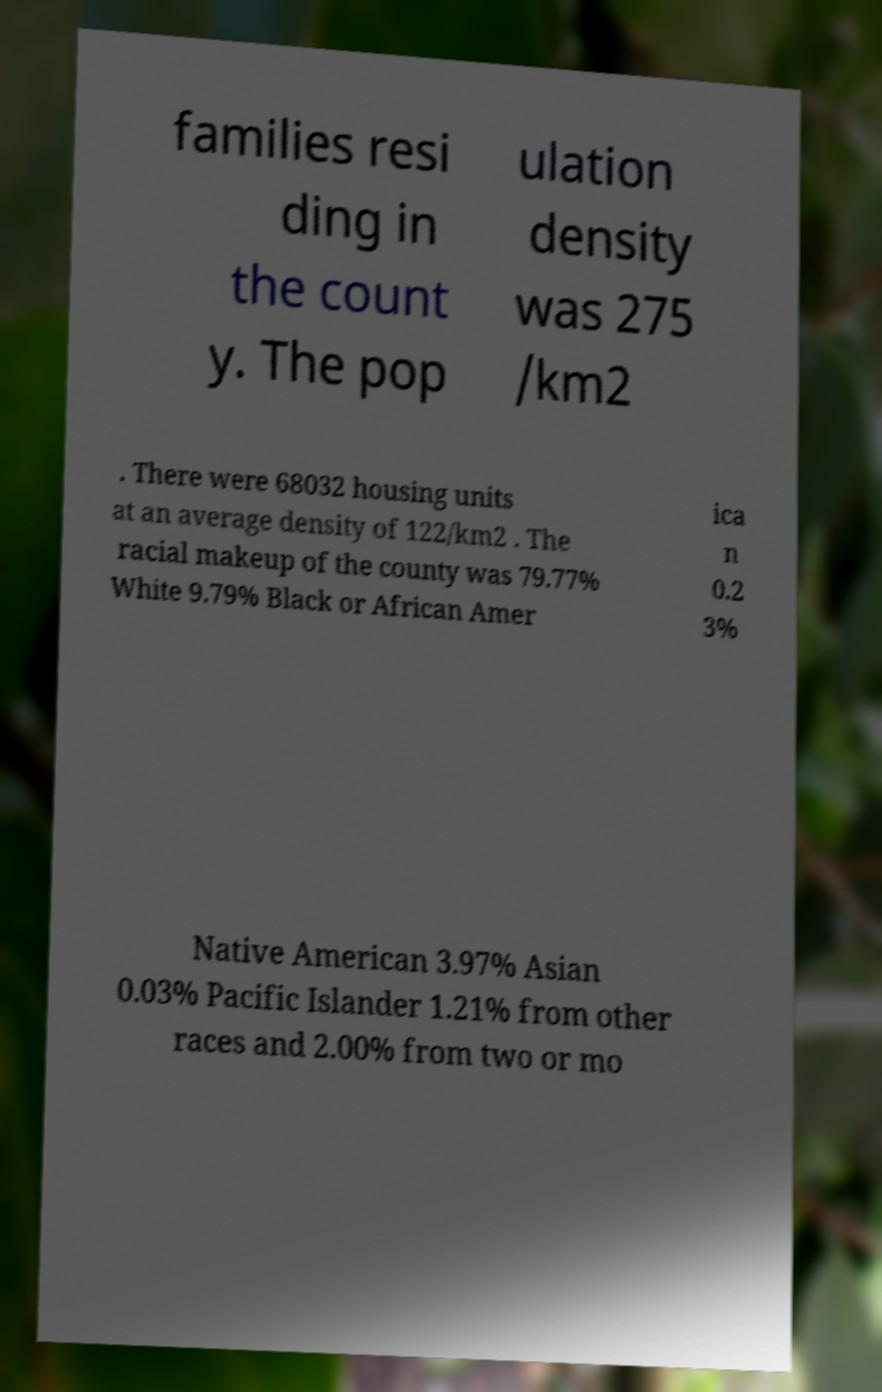For documentation purposes, I need the text within this image transcribed. Could you provide that? families resi ding in the count y. The pop ulation density was 275 /km2 . There were 68032 housing units at an average density of 122/km2 . The racial makeup of the county was 79.77% White 9.79% Black or African Amer ica n 0.2 3% Native American 3.97% Asian 0.03% Pacific Islander 1.21% from other races and 2.00% from two or mo 